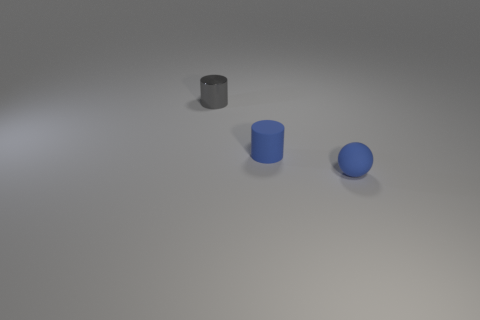Subtract 1 balls. How many balls are left? 0 Add 3 small blue cylinders. How many objects exist? 6 Subtract all cylinders. How many objects are left? 1 Subtract all blue cylinders. How many red balls are left? 0 Add 2 small blue things. How many small blue things exist? 4 Subtract 0 gray cubes. How many objects are left? 3 Subtract all green balls. Subtract all red blocks. How many balls are left? 1 Subtract all tiny purple rubber cylinders. Subtract all tiny gray cylinders. How many objects are left? 2 Add 1 small gray cylinders. How many small gray cylinders are left? 2 